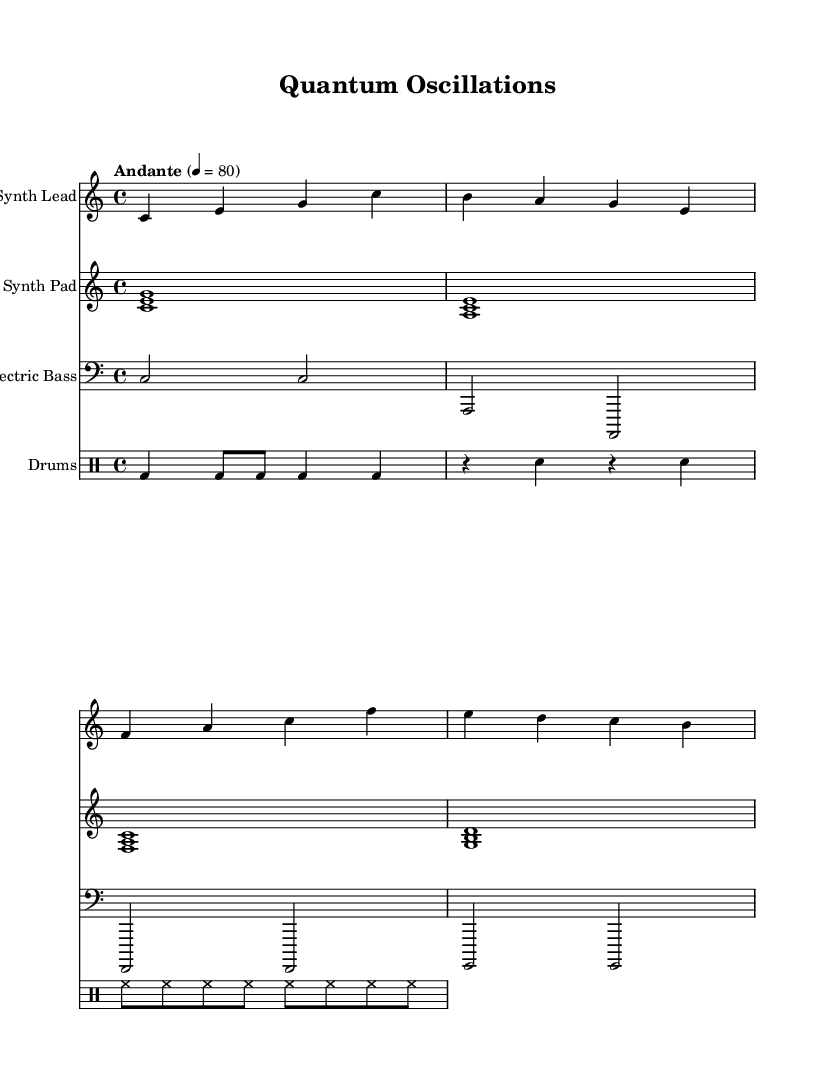What is the key signature of this music? The key signature is C major, which has no sharps or flats as indicated at the beginning of the score.
Answer: C major What is the time signature of this music? The time signature is 4/4, shown in the signature notation at the start of the piece, indicating four beats per measure.
Answer: 4/4 What is the tempo marking for this piece? The tempo marking is "Andante" at quarter note equals 80, indicating a moderate speed. This is found in the tempo indication at the beginning.
Answer: Andante How many measures are there in the synth lead? The synth lead section consists of four measures, which can be counted by observing the bar lines in the staff representation.
Answer: 4 Which instrument has the lowest pitch range? The electric bass typically has the lowest pitch range due to its clef (bass clef) and the choice of pitches being lower than the other parts.
Answer: Electric Bass What rhythmic pattern is primarily used in the drums part? The drums part utilizes a combination of bass drum and snare hits, with a regular pulse followed by alternating rests, which creates a driving rhythm.
Answer: Regular pulse Identify the primary harmony represented in the synth pad. The synth pad shows triads in the form of stacked intervals, primarily presenting major chords with roots on C, A, F, and G, indicating a harmonic foundation.
Answer: Major chords 